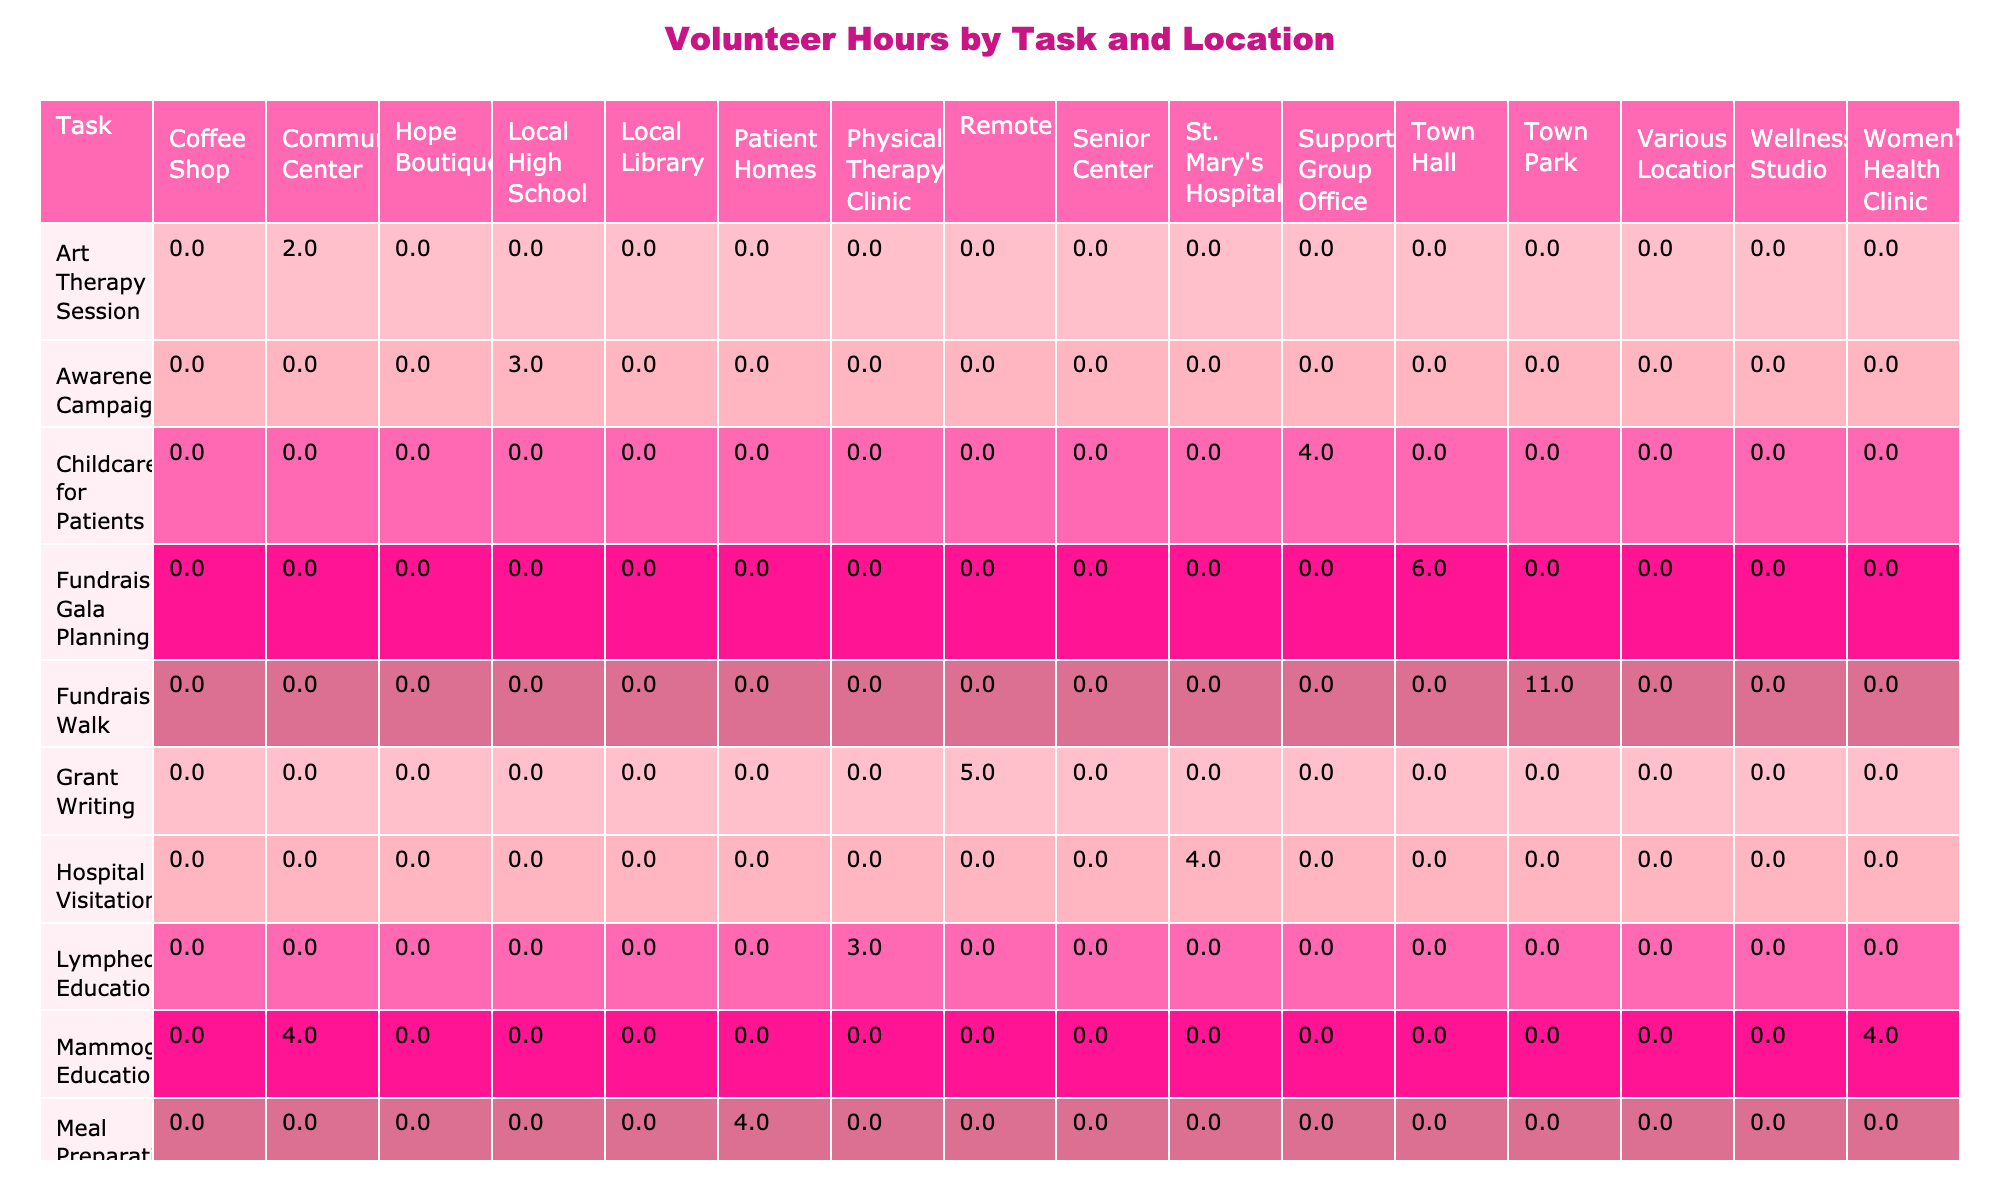What task received the highest number of volunteer hours? By examining the table, the task "Fundraising Walk" has the highest total of 11 hours (6 hours from Sarah Thompson and 5 hours from Donna Lee)
Answer: Fundraising Walk Which location had the lowest volunteer hours recorded? The "Support Group Office" had the lowest recorded hours with only 4 hours contributed to the childcare for patients task
Answer: Support Group Office What is the total number of hours volunteered for Mammogram Education? There are two entries for Mammogram Education: Mary Johnson contributed 4 hours and Sandra Brown contributed 4 hours. Adding these gives 4 + 4 = 8 hours total
Answer: 8 How many tasks received volunteer hours less than 3 hours? Looking at the table, only 2 tasks received less than 3 hours: "Yoga for Survivors" (1.5 hours) and "Survivor Story Sharing" (2 hours)
Answer: 2 Did any tasks take place at the Town Park? Yes, two tasks took place at Town Park: "Fundraising Walk" with a total of 11 hours
Answer: Yes Which age group served benefited the most from volunteer activities, based on total hours? Summing the hours for each age group served indicates: 'All Ages' (26 hours), '30-50' (9.5 hours), '60+' (6 hours), and others lesser. Therefore, 'All Ages' benefited the most.
Answer: All Ages What is the difference in volunteer hours between the task that received the highest hours and the task with the lowest hours? The task with the highest hours is "Fundraising Walk" with 11 hours, and the task with the lowest hours is "Yoga for Survivors" with 1.5 hours. The difference is 11 - 1.5 = 9.5 hours
Answer: 9.5 How many volunteers contributed to the Nutrition Workshop task? The Nutrition Workshop task was contributed by only one volunteer, Jennifer Lee, who dedicated 3 hours
Answer: 1 What is the average number of hours volunteered per task? There are 16 tasks recorded in total, and the total hours from all tasks is 58.5 hours. The average is calculated as 58.5 / 16, which is approximately 3.66 hours
Answer: 3.66 